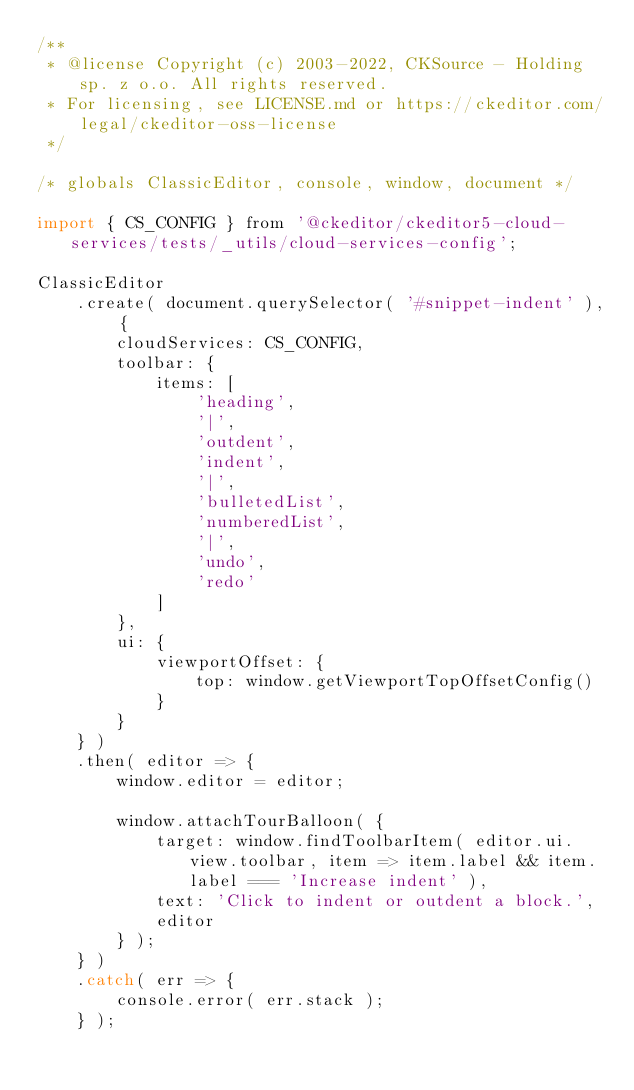<code> <loc_0><loc_0><loc_500><loc_500><_JavaScript_>/**
 * @license Copyright (c) 2003-2022, CKSource - Holding sp. z o.o. All rights reserved.
 * For licensing, see LICENSE.md or https://ckeditor.com/legal/ckeditor-oss-license
 */

/* globals ClassicEditor, console, window, document */

import { CS_CONFIG } from '@ckeditor/ckeditor5-cloud-services/tests/_utils/cloud-services-config';

ClassicEditor
	.create( document.querySelector( '#snippet-indent' ), {
		cloudServices: CS_CONFIG,
		toolbar: {
			items: [
				'heading',
				'|',
				'outdent',
				'indent',
				'|',
				'bulletedList',
				'numberedList',
				'|',
				'undo',
				'redo'
			]
		},
		ui: {
			viewportOffset: {
				top: window.getViewportTopOffsetConfig()
			}
		}
	} )
	.then( editor => {
		window.editor = editor;

		window.attachTourBalloon( {
			target: window.findToolbarItem( editor.ui.view.toolbar, item => item.label && item.label === 'Increase indent' ),
			text: 'Click to indent or outdent a block.',
			editor
		} );
	} )
	.catch( err => {
		console.error( err.stack );
	} );
</code> 